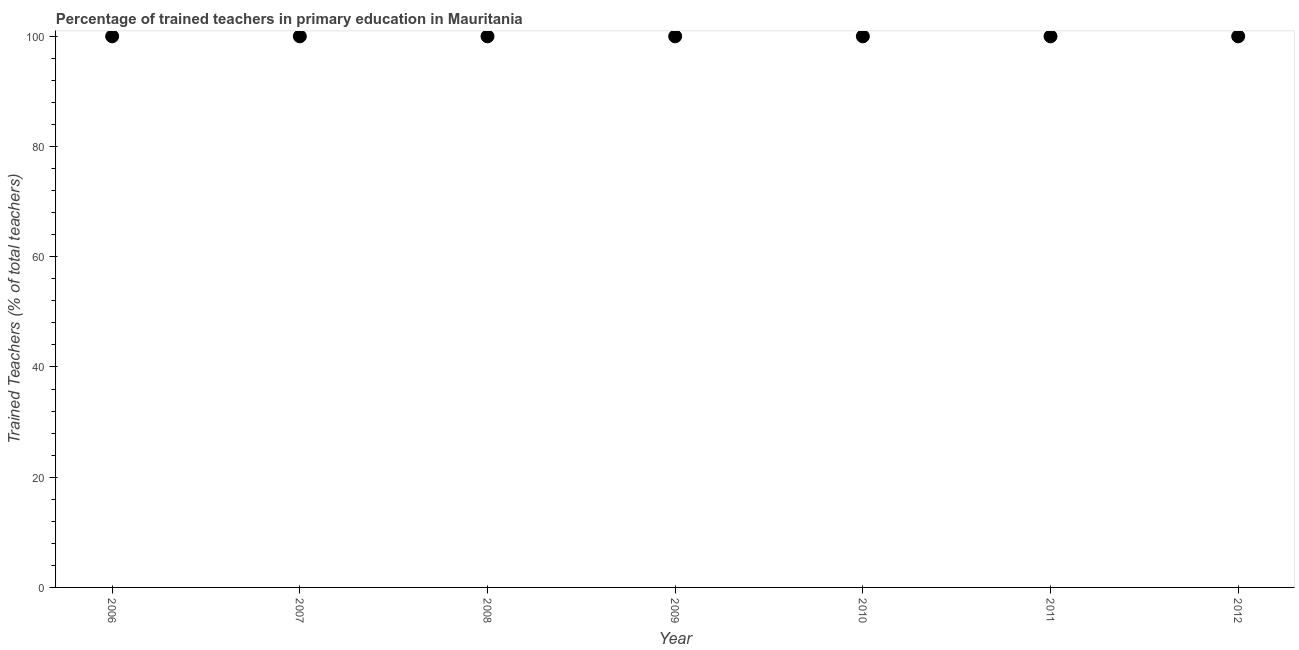What is the percentage of trained teachers in 2006?
Your answer should be compact. 100. Across all years, what is the maximum percentage of trained teachers?
Keep it short and to the point. 100. Across all years, what is the minimum percentage of trained teachers?
Offer a very short reply. 100. What is the sum of the percentage of trained teachers?
Keep it short and to the point. 700. What is the average percentage of trained teachers per year?
Your response must be concise. 100. What is the median percentage of trained teachers?
Offer a very short reply. 100. Is the percentage of trained teachers in 2007 less than that in 2008?
Offer a very short reply. No. Is the difference between the percentage of trained teachers in 2007 and 2012 greater than the difference between any two years?
Your response must be concise. Yes. What is the difference between the highest and the second highest percentage of trained teachers?
Offer a very short reply. 0. In how many years, is the percentage of trained teachers greater than the average percentage of trained teachers taken over all years?
Your response must be concise. 0. How many dotlines are there?
Make the answer very short. 1. How many years are there in the graph?
Offer a terse response. 7. What is the difference between two consecutive major ticks on the Y-axis?
Offer a very short reply. 20. Does the graph contain any zero values?
Make the answer very short. No. What is the title of the graph?
Your response must be concise. Percentage of trained teachers in primary education in Mauritania. What is the label or title of the Y-axis?
Ensure brevity in your answer.  Trained Teachers (% of total teachers). What is the Trained Teachers (% of total teachers) in 2008?
Your answer should be very brief. 100. What is the Trained Teachers (% of total teachers) in 2010?
Give a very brief answer. 100. What is the Trained Teachers (% of total teachers) in 2011?
Offer a terse response. 100. What is the difference between the Trained Teachers (% of total teachers) in 2006 and 2008?
Ensure brevity in your answer.  0. What is the difference between the Trained Teachers (% of total teachers) in 2006 and 2009?
Offer a terse response. 0. What is the difference between the Trained Teachers (% of total teachers) in 2006 and 2010?
Give a very brief answer. 0. What is the difference between the Trained Teachers (% of total teachers) in 2007 and 2008?
Offer a very short reply. 0. What is the difference between the Trained Teachers (% of total teachers) in 2007 and 2011?
Ensure brevity in your answer.  0. What is the difference between the Trained Teachers (% of total teachers) in 2007 and 2012?
Offer a terse response. 0. What is the difference between the Trained Teachers (% of total teachers) in 2008 and 2010?
Offer a very short reply. 0. What is the difference between the Trained Teachers (% of total teachers) in 2009 and 2011?
Offer a terse response. 0. What is the difference between the Trained Teachers (% of total teachers) in 2010 and 2011?
Provide a succinct answer. 0. What is the difference between the Trained Teachers (% of total teachers) in 2010 and 2012?
Keep it short and to the point. 0. What is the ratio of the Trained Teachers (% of total teachers) in 2006 to that in 2007?
Make the answer very short. 1. What is the ratio of the Trained Teachers (% of total teachers) in 2006 to that in 2008?
Provide a succinct answer. 1. What is the ratio of the Trained Teachers (% of total teachers) in 2006 to that in 2011?
Offer a terse response. 1. What is the ratio of the Trained Teachers (% of total teachers) in 2006 to that in 2012?
Offer a very short reply. 1. What is the ratio of the Trained Teachers (% of total teachers) in 2007 to that in 2008?
Make the answer very short. 1. What is the ratio of the Trained Teachers (% of total teachers) in 2007 to that in 2009?
Make the answer very short. 1. What is the ratio of the Trained Teachers (% of total teachers) in 2007 to that in 2010?
Offer a terse response. 1. What is the ratio of the Trained Teachers (% of total teachers) in 2008 to that in 2009?
Make the answer very short. 1. What is the ratio of the Trained Teachers (% of total teachers) in 2008 to that in 2011?
Offer a very short reply. 1. What is the ratio of the Trained Teachers (% of total teachers) in 2008 to that in 2012?
Offer a very short reply. 1. What is the ratio of the Trained Teachers (% of total teachers) in 2009 to that in 2010?
Offer a very short reply. 1. 